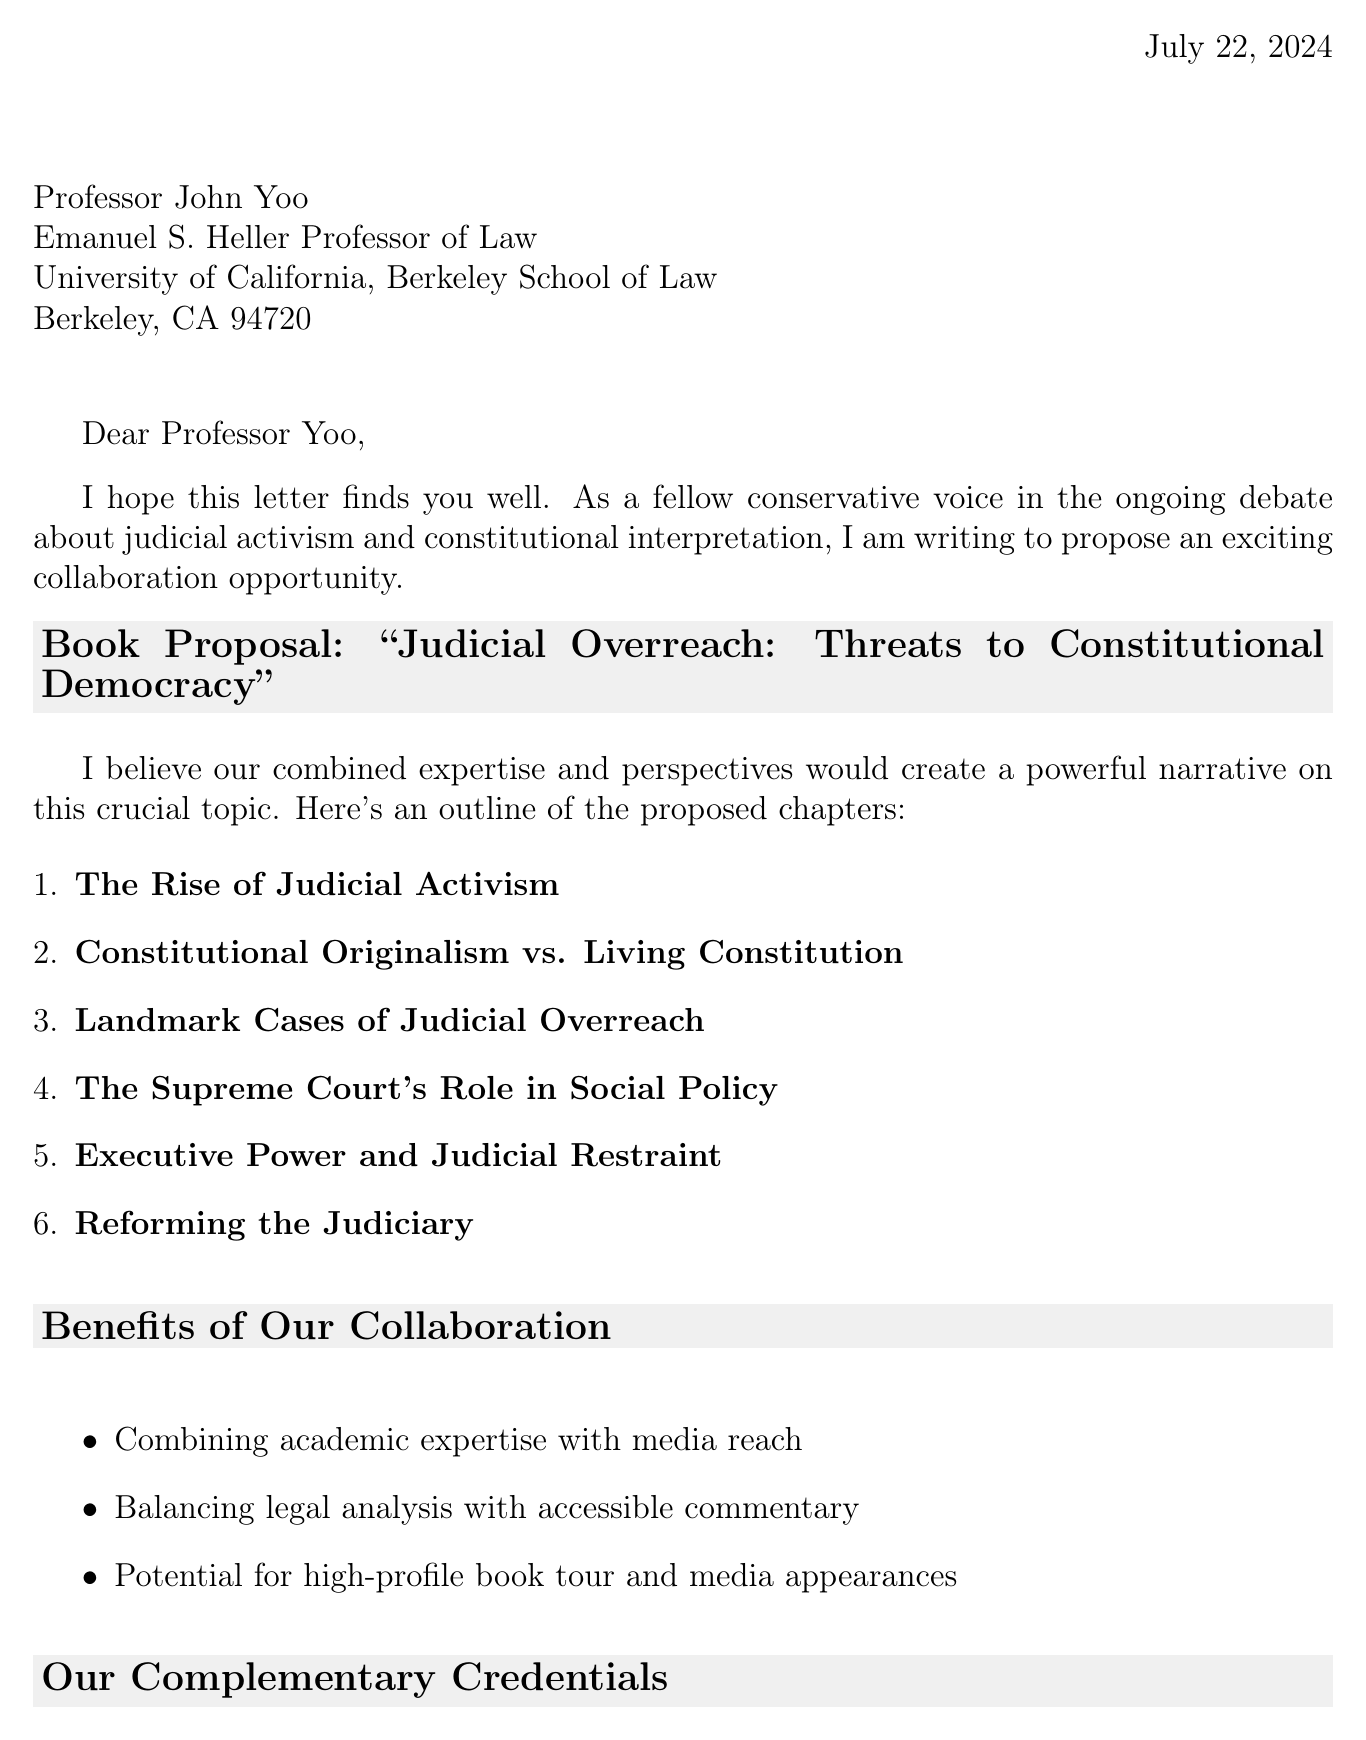What is the title of the proposed book? The title of the proposed book is mentioned in the heading box of the letter.
Answer: Judicial Overreach: Threats to Constitutional Democracy Who is the recipient of the letter? The recipient's name and title are provided at the beginning of the letter.
Answer: Professor John Yoo What is the name of the radio show hosted by the sender? The radio show name is referenced in the sender's credentials section.
Answer: The Conservative Conscience Which chapter discusses landmark cases of judicial overreach? The chapters are outlined in the list, and this specific chapter title is related to the subject matter of judicial overreach.
Answer: Landmark Cases of Judicial Overreach How many weekly listeners does the sender’s radio show have? The number of weekly listeners is explicitly stated in the sender's platform details.
Answer: 5 million What is one potential publisher mentioned for the book? This information can be found in the section discussing potential publishing houses.
Answer: Regnery Publishing Which chapter focuses on the role of the Supreme Court in social policy? The title of the chapter related to this topic is listed in the proposed chapters.
Answer: The Supreme Court's Role in Social Policy What is one benefit of the proposed collaboration? Benefits of collaboration are listed clearly, detailing what the co-authors would achieve together.
Answer: Combining academic expertise with media reach What is a proposed reform mentioned for the judiciary? The proposed reforms are outlined in the chapters and provide topics for discussion on judiciary changes.
Answer: Term limits for Supreme Court Justices 